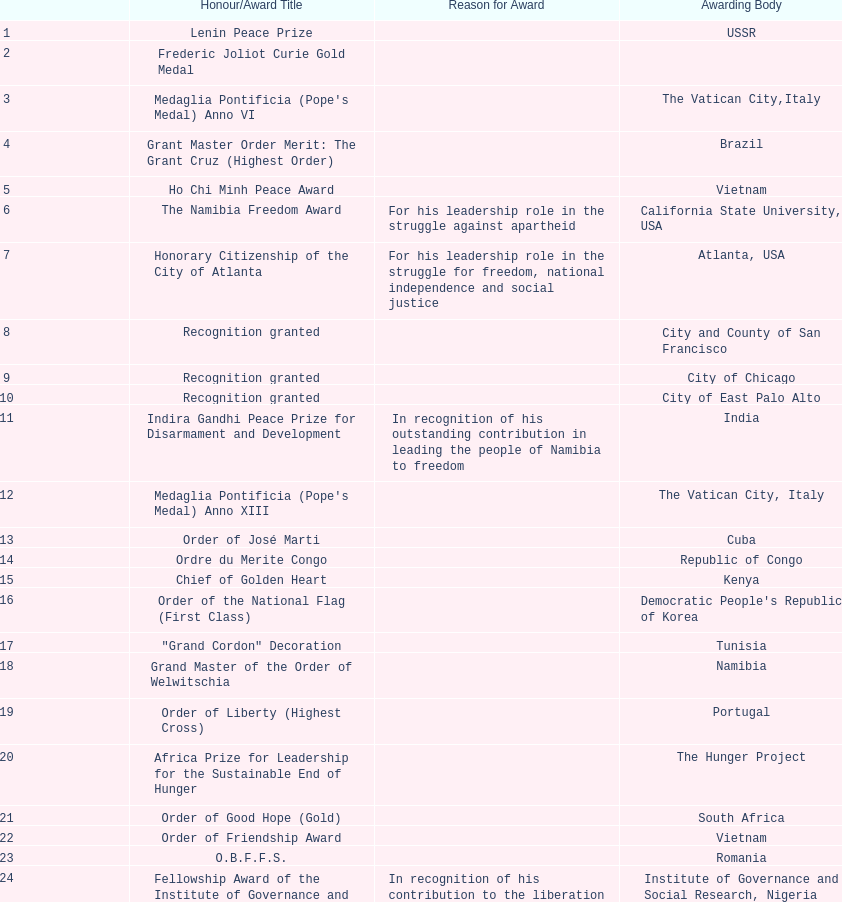Could you help me parse every detail presented in this table? {'header': ['', 'Honour/Award Title', 'Reason for Award', 'Awarding Body'], 'rows': [['1', 'Lenin Peace Prize', '', 'USSR'], ['2', 'Frederic Joliot Curie Gold Medal', '', ''], ['3', "Medaglia Pontificia (Pope's Medal) Anno VI", '', 'The Vatican City,Italy'], ['4', 'Grant Master Order Merit: The Grant Cruz (Highest Order)', '', 'Brazil'], ['5', 'Ho Chi Minh Peace Award', '', 'Vietnam'], ['6', 'The Namibia Freedom Award', 'For his leadership role in the struggle against apartheid', 'California State University, USA'], ['7', 'Honorary Citizenship of the City of Atlanta', 'For his leadership role in the struggle for freedom, national independence and social justice', 'Atlanta, USA'], ['8', 'Recognition granted', '', 'City and County of San Francisco'], ['9', 'Recognition granted', '', 'City of Chicago'], ['10', 'Recognition granted', '', 'City of East Palo Alto'], ['11', 'Indira Gandhi Peace Prize for Disarmament and Development', 'In recognition of his outstanding contribution in leading the people of Namibia to freedom', 'India'], ['12', "Medaglia Pontificia (Pope's Medal) Anno XIII", '', 'The Vatican City, Italy'], ['13', 'Order of José Marti', '', 'Cuba'], ['14', 'Ordre du Merite Congo', '', 'Republic of Congo'], ['15', 'Chief of Golden Heart', '', 'Kenya'], ['16', 'Order of the National Flag (First Class)', '', "Democratic People's Republic of Korea"], ['17', '"Grand Cordon" Decoration', '', 'Tunisia'], ['18', 'Grand Master of the Order of Welwitschia', '', 'Namibia'], ['19', 'Order of Liberty (Highest Cross)', '', 'Portugal'], ['20', 'Africa Prize for Leadership for the Sustainable End of Hunger', '', 'The Hunger Project'], ['21', 'Order of Good Hope (Gold)', '', 'South Africa'], ['22', 'Order of Friendship Award', '', 'Vietnam'], ['23', 'O.B.F.F.S.', '', 'Romania'], ['24', 'Fellowship Award of the Institute of Governance and Social Research', 'In recognition of his contribution to the liberation of his country, the establishment of Democratic foundation, peace and Political stability in Namibia, and the enhancement of the dignity of the Black Man', 'Institute of Governance and Social Research, Nigeria'], ['25', 'Companion of the Order of the Star of Ghana (Ghana National Highest Award)', 'As an expression of respect and admiration of the Government and people of Ghana', 'Ghana'], ['26', 'Founding President of the Republic of Namibia and Father of the Namibian Nation', 'In recognition of his dedication to his selfless sacrifice to the national liberation struggle and nation building', 'Namibian Parliament'], ['27', 'Lifetime Conservation Award', '', 'Cheetah Conservation Fund (Nujoma is the international patron of this organisation since 1991)'], ['28', 'International KIM IL Sung Prize Certificate', '', 'India'], ['29', 'Sir Seretse Khama SADC Meda', '', 'SADC']]} Which year was the most honors/award titles given? 1988. 